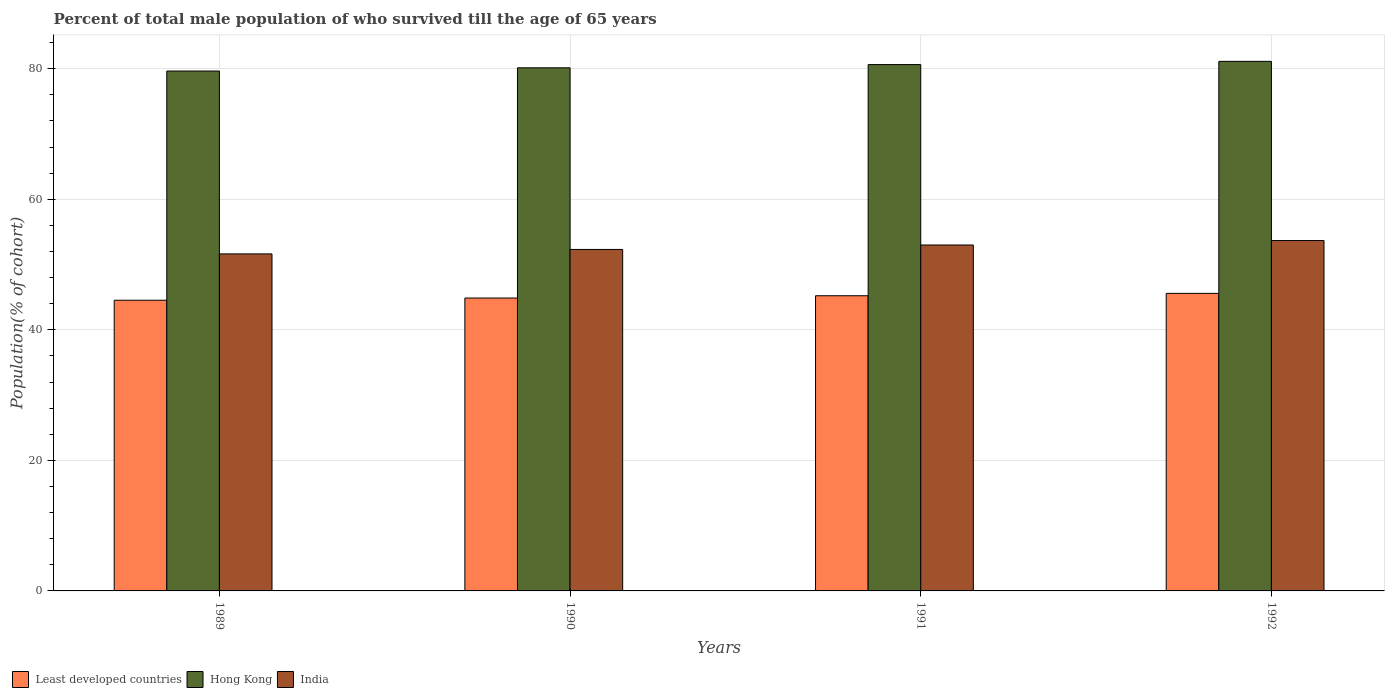Are the number of bars on each tick of the X-axis equal?
Provide a short and direct response. Yes. How many bars are there on the 4th tick from the right?
Your response must be concise. 3. What is the label of the 4th group of bars from the left?
Your answer should be very brief. 1992. What is the percentage of total male population who survived till the age of 65 years in India in 1992?
Provide a succinct answer. 53.68. Across all years, what is the maximum percentage of total male population who survived till the age of 65 years in Hong Kong?
Make the answer very short. 81.12. Across all years, what is the minimum percentage of total male population who survived till the age of 65 years in India?
Ensure brevity in your answer.  51.63. In which year was the percentage of total male population who survived till the age of 65 years in Hong Kong maximum?
Provide a short and direct response. 1992. In which year was the percentage of total male population who survived till the age of 65 years in Hong Kong minimum?
Offer a terse response. 1989. What is the total percentage of total male population who survived till the age of 65 years in Hong Kong in the graph?
Ensure brevity in your answer.  321.53. What is the difference between the percentage of total male population who survived till the age of 65 years in Least developed countries in 1989 and that in 1992?
Make the answer very short. -1.05. What is the difference between the percentage of total male population who survived till the age of 65 years in India in 1992 and the percentage of total male population who survived till the age of 65 years in Hong Kong in 1991?
Offer a very short reply. -26.95. What is the average percentage of total male population who survived till the age of 65 years in Least developed countries per year?
Your answer should be very brief. 45.05. In the year 1990, what is the difference between the percentage of total male population who survived till the age of 65 years in Least developed countries and percentage of total male population who survived till the age of 65 years in Hong Kong?
Make the answer very short. -35.27. What is the ratio of the percentage of total male population who survived till the age of 65 years in India in 1990 to that in 1991?
Provide a succinct answer. 0.99. Is the percentage of total male population who survived till the age of 65 years in Least developed countries in 1989 less than that in 1991?
Your response must be concise. Yes. Is the difference between the percentage of total male population who survived till the age of 65 years in Least developed countries in 1989 and 1992 greater than the difference between the percentage of total male population who survived till the age of 65 years in Hong Kong in 1989 and 1992?
Your answer should be very brief. Yes. What is the difference between the highest and the second highest percentage of total male population who survived till the age of 65 years in Hong Kong?
Provide a succinct answer. 0.49. What is the difference between the highest and the lowest percentage of total male population who survived till the age of 65 years in Hong Kong?
Provide a succinct answer. 1.48. In how many years, is the percentage of total male population who survived till the age of 65 years in Least developed countries greater than the average percentage of total male population who survived till the age of 65 years in Least developed countries taken over all years?
Provide a short and direct response. 2. Is the sum of the percentage of total male population who survived till the age of 65 years in India in 1989 and 1991 greater than the maximum percentage of total male population who survived till the age of 65 years in Hong Kong across all years?
Provide a short and direct response. Yes. Is it the case that in every year, the sum of the percentage of total male population who survived till the age of 65 years in India and percentage of total male population who survived till the age of 65 years in Hong Kong is greater than the percentage of total male population who survived till the age of 65 years in Least developed countries?
Offer a terse response. Yes. Are all the bars in the graph horizontal?
Offer a terse response. No. What is the difference between two consecutive major ticks on the Y-axis?
Keep it short and to the point. 20. Are the values on the major ticks of Y-axis written in scientific E-notation?
Provide a succinct answer. No. Where does the legend appear in the graph?
Provide a short and direct response. Bottom left. How many legend labels are there?
Your answer should be compact. 3. What is the title of the graph?
Ensure brevity in your answer.  Percent of total male population of who survived till the age of 65 years. What is the label or title of the X-axis?
Keep it short and to the point. Years. What is the label or title of the Y-axis?
Ensure brevity in your answer.  Population(% of cohort). What is the Population(% of cohort) of Least developed countries in 1989?
Your answer should be very brief. 44.53. What is the Population(% of cohort) of Hong Kong in 1989?
Offer a very short reply. 79.64. What is the Population(% of cohort) in India in 1989?
Keep it short and to the point. 51.63. What is the Population(% of cohort) in Least developed countries in 1990?
Give a very brief answer. 44.87. What is the Population(% of cohort) of Hong Kong in 1990?
Make the answer very short. 80.14. What is the Population(% of cohort) in India in 1990?
Offer a very short reply. 52.31. What is the Population(% of cohort) of Least developed countries in 1991?
Ensure brevity in your answer.  45.22. What is the Population(% of cohort) of Hong Kong in 1991?
Offer a terse response. 80.63. What is the Population(% of cohort) of India in 1991?
Offer a very short reply. 52.99. What is the Population(% of cohort) in Least developed countries in 1992?
Your response must be concise. 45.58. What is the Population(% of cohort) in Hong Kong in 1992?
Provide a succinct answer. 81.12. What is the Population(% of cohort) in India in 1992?
Ensure brevity in your answer.  53.68. Across all years, what is the maximum Population(% of cohort) in Least developed countries?
Your response must be concise. 45.58. Across all years, what is the maximum Population(% of cohort) in Hong Kong?
Keep it short and to the point. 81.12. Across all years, what is the maximum Population(% of cohort) of India?
Offer a very short reply. 53.68. Across all years, what is the minimum Population(% of cohort) of Least developed countries?
Offer a very short reply. 44.53. Across all years, what is the minimum Population(% of cohort) in Hong Kong?
Your response must be concise. 79.64. Across all years, what is the minimum Population(% of cohort) of India?
Your answer should be compact. 51.63. What is the total Population(% of cohort) in Least developed countries in the graph?
Keep it short and to the point. 180.2. What is the total Population(% of cohort) of Hong Kong in the graph?
Keep it short and to the point. 321.53. What is the total Population(% of cohort) in India in the graph?
Your answer should be very brief. 210.61. What is the difference between the Population(% of cohort) in Least developed countries in 1989 and that in 1990?
Offer a very short reply. -0.33. What is the difference between the Population(% of cohort) in Hong Kong in 1989 and that in 1990?
Offer a terse response. -0.49. What is the difference between the Population(% of cohort) of India in 1989 and that in 1990?
Provide a short and direct response. -0.68. What is the difference between the Population(% of cohort) in Least developed countries in 1989 and that in 1991?
Provide a succinct answer. -0.69. What is the difference between the Population(% of cohort) of Hong Kong in 1989 and that in 1991?
Provide a short and direct response. -0.99. What is the difference between the Population(% of cohort) of India in 1989 and that in 1991?
Provide a short and direct response. -1.36. What is the difference between the Population(% of cohort) in Least developed countries in 1989 and that in 1992?
Provide a short and direct response. -1.05. What is the difference between the Population(% of cohort) in Hong Kong in 1989 and that in 1992?
Offer a very short reply. -1.48. What is the difference between the Population(% of cohort) in India in 1989 and that in 1992?
Offer a very short reply. -2.05. What is the difference between the Population(% of cohort) in Least developed countries in 1990 and that in 1991?
Your answer should be compact. -0.35. What is the difference between the Population(% of cohort) of Hong Kong in 1990 and that in 1991?
Your answer should be very brief. -0.49. What is the difference between the Population(% of cohort) of India in 1990 and that in 1991?
Offer a very short reply. -0.68. What is the difference between the Population(% of cohort) of Least developed countries in 1990 and that in 1992?
Make the answer very short. -0.72. What is the difference between the Population(% of cohort) of Hong Kong in 1990 and that in 1992?
Your answer should be very brief. -0.99. What is the difference between the Population(% of cohort) in India in 1990 and that in 1992?
Ensure brevity in your answer.  -1.36. What is the difference between the Population(% of cohort) in Least developed countries in 1991 and that in 1992?
Offer a terse response. -0.36. What is the difference between the Population(% of cohort) in Hong Kong in 1991 and that in 1992?
Provide a succinct answer. -0.49. What is the difference between the Population(% of cohort) of India in 1991 and that in 1992?
Your answer should be compact. -0.68. What is the difference between the Population(% of cohort) of Least developed countries in 1989 and the Population(% of cohort) of Hong Kong in 1990?
Give a very brief answer. -35.6. What is the difference between the Population(% of cohort) of Least developed countries in 1989 and the Population(% of cohort) of India in 1990?
Provide a short and direct response. -7.78. What is the difference between the Population(% of cohort) in Hong Kong in 1989 and the Population(% of cohort) in India in 1990?
Offer a terse response. 27.33. What is the difference between the Population(% of cohort) in Least developed countries in 1989 and the Population(% of cohort) in Hong Kong in 1991?
Ensure brevity in your answer.  -36.1. What is the difference between the Population(% of cohort) of Least developed countries in 1989 and the Population(% of cohort) of India in 1991?
Keep it short and to the point. -8.46. What is the difference between the Population(% of cohort) of Hong Kong in 1989 and the Population(% of cohort) of India in 1991?
Make the answer very short. 26.65. What is the difference between the Population(% of cohort) in Least developed countries in 1989 and the Population(% of cohort) in Hong Kong in 1992?
Your answer should be very brief. -36.59. What is the difference between the Population(% of cohort) in Least developed countries in 1989 and the Population(% of cohort) in India in 1992?
Your answer should be very brief. -9.14. What is the difference between the Population(% of cohort) of Hong Kong in 1989 and the Population(% of cohort) of India in 1992?
Provide a succinct answer. 25.97. What is the difference between the Population(% of cohort) of Least developed countries in 1990 and the Population(% of cohort) of Hong Kong in 1991?
Make the answer very short. -35.76. What is the difference between the Population(% of cohort) of Least developed countries in 1990 and the Population(% of cohort) of India in 1991?
Provide a succinct answer. -8.13. What is the difference between the Population(% of cohort) of Hong Kong in 1990 and the Population(% of cohort) of India in 1991?
Make the answer very short. 27.14. What is the difference between the Population(% of cohort) in Least developed countries in 1990 and the Population(% of cohort) in Hong Kong in 1992?
Give a very brief answer. -36.26. What is the difference between the Population(% of cohort) in Least developed countries in 1990 and the Population(% of cohort) in India in 1992?
Offer a terse response. -8.81. What is the difference between the Population(% of cohort) in Hong Kong in 1990 and the Population(% of cohort) in India in 1992?
Your response must be concise. 26.46. What is the difference between the Population(% of cohort) in Least developed countries in 1991 and the Population(% of cohort) in Hong Kong in 1992?
Ensure brevity in your answer.  -35.91. What is the difference between the Population(% of cohort) of Least developed countries in 1991 and the Population(% of cohort) of India in 1992?
Provide a short and direct response. -8.46. What is the difference between the Population(% of cohort) of Hong Kong in 1991 and the Population(% of cohort) of India in 1992?
Offer a terse response. 26.95. What is the average Population(% of cohort) of Least developed countries per year?
Provide a short and direct response. 45.05. What is the average Population(% of cohort) of Hong Kong per year?
Offer a terse response. 80.38. What is the average Population(% of cohort) in India per year?
Offer a terse response. 52.65. In the year 1989, what is the difference between the Population(% of cohort) in Least developed countries and Population(% of cohort) in Hong Kong?
Give a very brief answer. -35.11. In the year 1989, what is the difference between the Population(% of cohort) in Least developed countries and Population(% of cohort) in India?
Ensure brevity in your answer.  -7.1. In the year 1989, what is the difference between the Population(% of cohort) of Hong Kong and Population(% of cohort) of India?
Your response must be concise. 28.01. In the year 1990, what is the difference between the Population(% of cohort) in Least developed countries and Population(% of cohort) in Hong Kong?
Your response must be concise. -35.27. In the year 1990, what is the difference between the Population(% of cohort) in Least developed countries and Population(% of cohort) in India?
Your answer should be compact. -7.44. In the year 1990, what is the difference between the Population(% of cohort) in Hong Kong and Population(% of cohort) in India?
Give a very brief answer. 27.83. In the year 1991, what is the difference between the Population(% of cohort) in Least developed countries and Population(% of cohort) in Hong Kong?
Make the answer very short. -35.41. In the year 1991, what is the difference between the Population(% of cohort) of Least developed countries and Population(% of cohort) of India?
Offer a very short reply. -7.77. In the year 1991, what is the difference between the Population(% of cohort) in Hong Kong and Population(% of cohort) in India?
Your answer should be very brief. 27.64. In the year 1992, what is the difference between the Population(% of cohort) in Least developed countries and Population(% of cohort) in Hong Kong?
Provide a succinct answer. -35.54. In the year 1992, what is the difference between the Population(% of cohort) of Least developed countries and Population(% of cohort) of India?
Your answer should be very brief. -8.09. In the year 1992, what is the difference between the Population(% of cohort) of Hong Kong and Population(% of cohort) of India?
Provide a succinct answer. 27.45. What is the ratio of the Population(% of cohort) in Least developed countries in 1989 to that in 1991?
Keep it short and to the point. 0.98. What is the ratio of the Population(% of cohort) in India in 1989 to that in 1991?
Your answer should be very brief. 0.97. What is the ratio of the Population(% of cohort) in Least developed countries in 1989 to that in 1992?
Your answer should be very brief. 0.98. What is the ratio of the Population(% of cohort) of Hong Kong in 1989 to that in 1992?
Your answer should be compact. 0.98. What is the ratio of the Population(% of cohort) of India in 1989 to that in 1992?
Keep it short and to the point. 0.96. What is the ratio of the Population(% of cohort) in India in 1990 to that in 1991?
Offer a very short reply. 0.99. What is the ratio of the Population(% of cohort) in Least developed countries in 1990 to that in 1992?
Ensure brevity in your answer.  0.98. What is the ratio of the Population(% of cohort) of India in 1990 to that in 1992?
Your answer should be compact. 0.97. What is the ratio of the Population(% of cohort) of Least developed countries in 1991 to that in 1992?
Keep it short and to the point. 0.99. What is the ratio of the Population(% of cohort) in Hong Kong in 1991 to that in 1992?
Provide a succinct answer. 0.99. What is the ratio of the Population(% of cohort) of India in 1991 to that in 1992?
Make the answer very short. 0.99. What is the difference between the highest and the second highest Population(% of cohort) in Least developed countries?
Give a very brief answer. 0.36. What is the difference between the highest and the second highest Population(% of cohort) of Hong Kong?
Give a very brief answer. 0.49. What is the difference between the highest and the second highest Population(% of cohort) of India?
Your response must be concise. 0.68. What is the difference between the highest and the lowest Population(% of cohort) in Least developed countries?
Offer a terse response. 1.05. What is the difference between the highest and the lowest Population(% of cohort) of Hong Kong?
Your answer should be very brief. 1.48. What is the difference between the highest and the lowest Population(% of cohort) in India?
Provide a short and direct response. 2.05. 